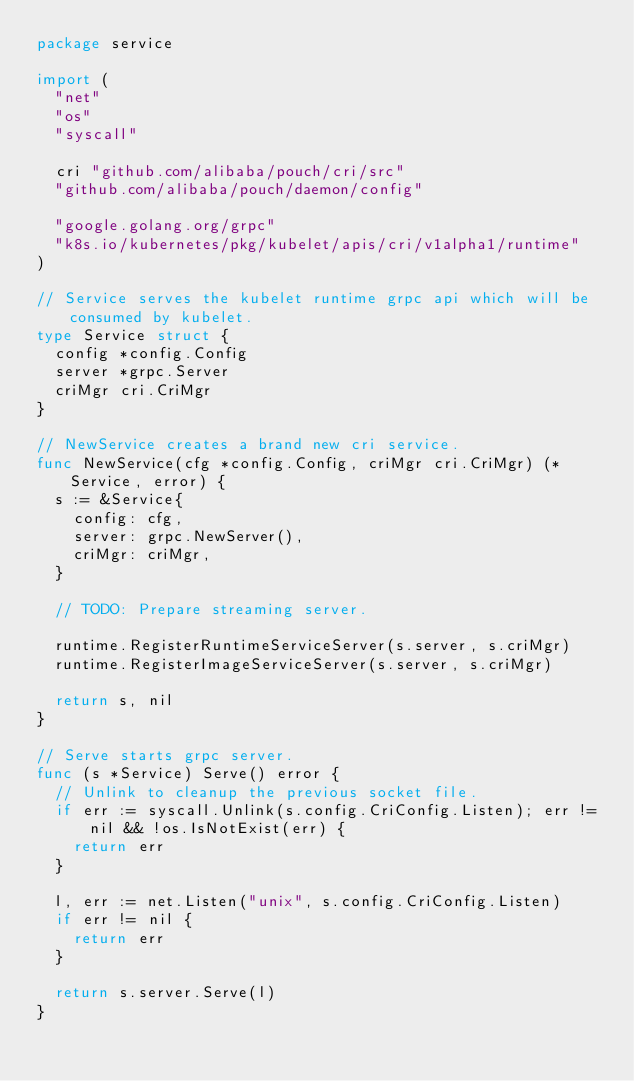<code> <loc_0><loc_0><loc_500><loc_500><_Go_>package service

import (
	"net"
	"os"
	"syscall"

	cri "github.com/alibaba/pouch/cri/src"
	"github.com/alibaba/pouch/daemon/config"

	"google.golang.org/grpc"
	"k8s.io/kubernetes/pkg/kubelet/apis/cri/v1alpha1/runtime"
)

// Service serves the kubelet runtime grpc api which will be consumed by kubelet.
type Service struct {
	config *config.Config
	server *grpc.Server
	criMgr cri.CriMgr
}

// NewService creates a brand new cri service.
func NewService(cfg *config.Config, criMgr cri.CriMgr) (*Service, error) {
	s := &Service{
		config: cfg,
		server: grpc.NewServer(),
		criMgr: criMgr,
	}

	// TODO: Prepare streaming server.

	runtime.RegisterRuntimeServiceServer(s.server, s.criMgr)
	runtime.RegisterImageServiceServer(s.server, s.criMgr)

	return s, nil
}

// Serve starts grpc server.
func (s *Service) Serve() error {
	// Unlink to cleanup the previous socket file.
	if err := syscall.Unlink(s.config.CriConfig.Listen); err != nil && !os.IsNotExist(err) {
		return err
	}

	l, err := net.Listen("unix", s.config.CriConfig.Listen)
	if err != nil {
		return err
	}

	return s.server.Serve(l)
}
</code> 